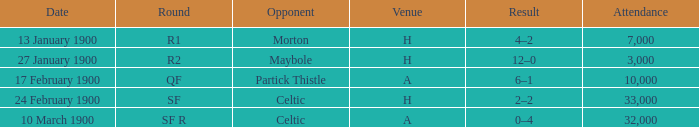What round did the celtic played away on 24 february 1900? SF. 